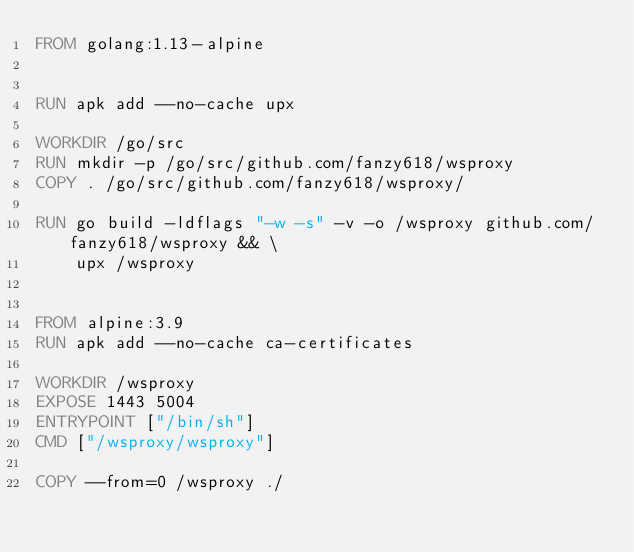<code> <loc_0><loc_0><loc_500><loc_500><_Dockerfile_>FROM golang:1.13-alpine


RUN apk add --no-cache upx

WORKDIR /go/src
RUN mkdir -p /go/src/github.com/fanzy618/wsproxy
COPY . /go/src/github.com/fanzy618/wsproxy/

RUN go build -ldflags "-w -s" -v -o /wsproxy github.com/fanzy618/wsproxy && \
    upx /wsproxy


FROM alpine:3.9
RUN apk add --no-cache ca-certificates

WORKDIR /wsproxy
EXPOSE 1443 5004
ENTRYPOINT ["/bin/sh"]
CMD ["/wsproxy/wsproxy"]

COPY --from=0 /wsproxy ./
</code> 